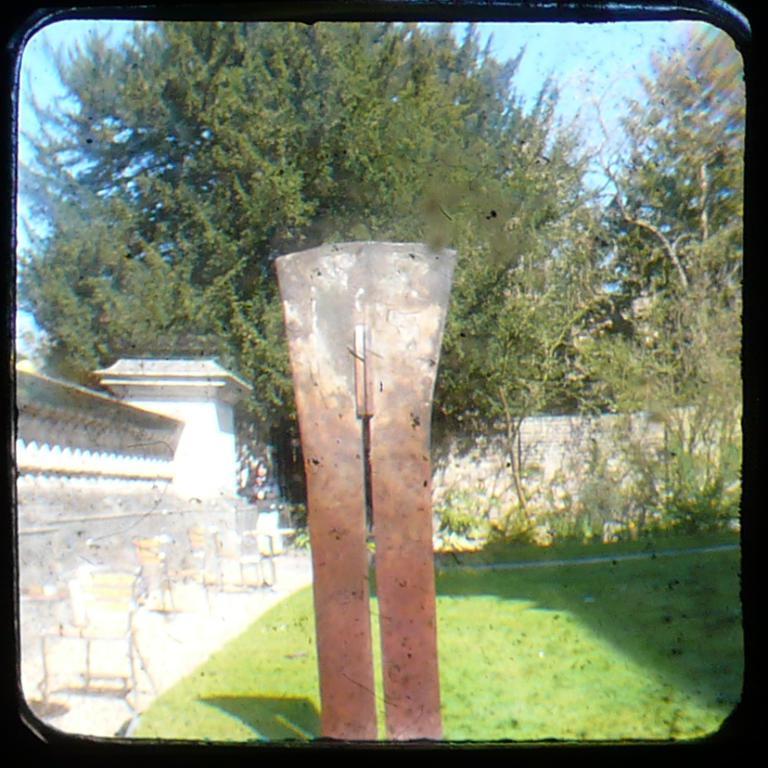Please provide a concise description of this image. In the foreground of the picture there are chairs, tables, grass and plants. In the background there are trees. Sky is clear and it is sunny bro. 